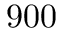<formula> <loc_0><loc_0><loc_500><loc_500>9 0 0</formula> 